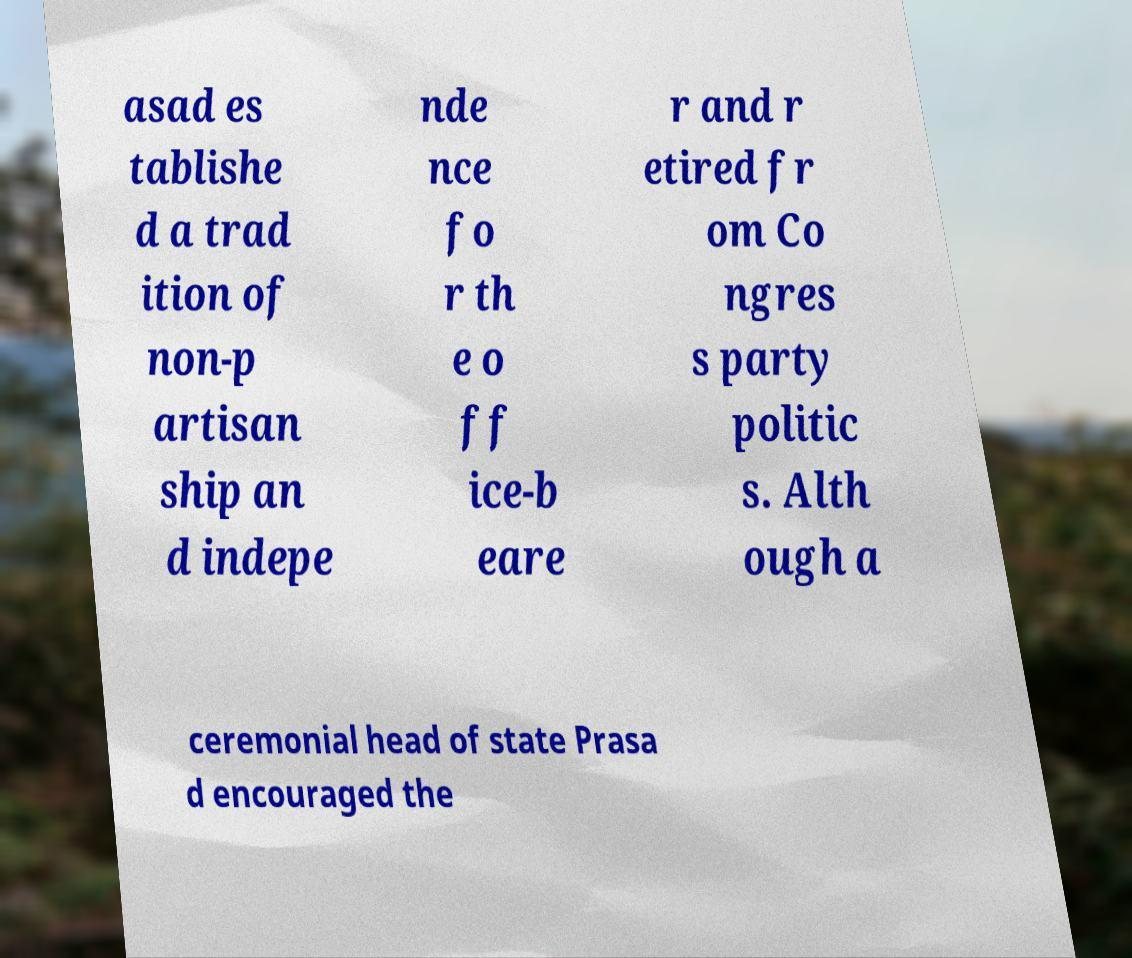Can you read and provide the text displayed in the image?This photo seems to have some interesting text. Can you extract and type it out for me? asad es tablishe d a trad ition of non-p artisan ship an d indepe nde nce fo r th e o ff ice-b eare r and r etired fr om Co ngres s party politic s. Alth ough a ceremonial head of state Prasa d encouraged the 